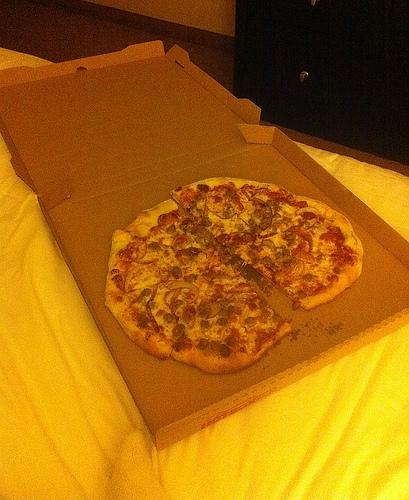Question: where is this scene?
Choices:
A. In the guest room.
B. In the kitchen.
C. In the living room.
D. In the bedroom.
Answer with the letter. Answer: B Question: what is in the photo?
Choices:
A. Pizza.
B. Wine.
C. Water.
D. People at a party.
Answer with the letter. Answer: A Question: who is in the photo?
Choices:
A. Two women.
B. A couple dancing.
C. No one.
D. The governor.
Answer with the letter. Answer: C Question: how is the pizza?
Choices:
A. Round.
B. Covered with meats.
C. Uncut.
D. Steaming.
Answer with the letter. Answer: A Question: what else is in the photo?
Choices:
A. Tiger.
B. Table.
C. Lltter.
D. Sidewalk.
Answer with the letter. Answer: B 